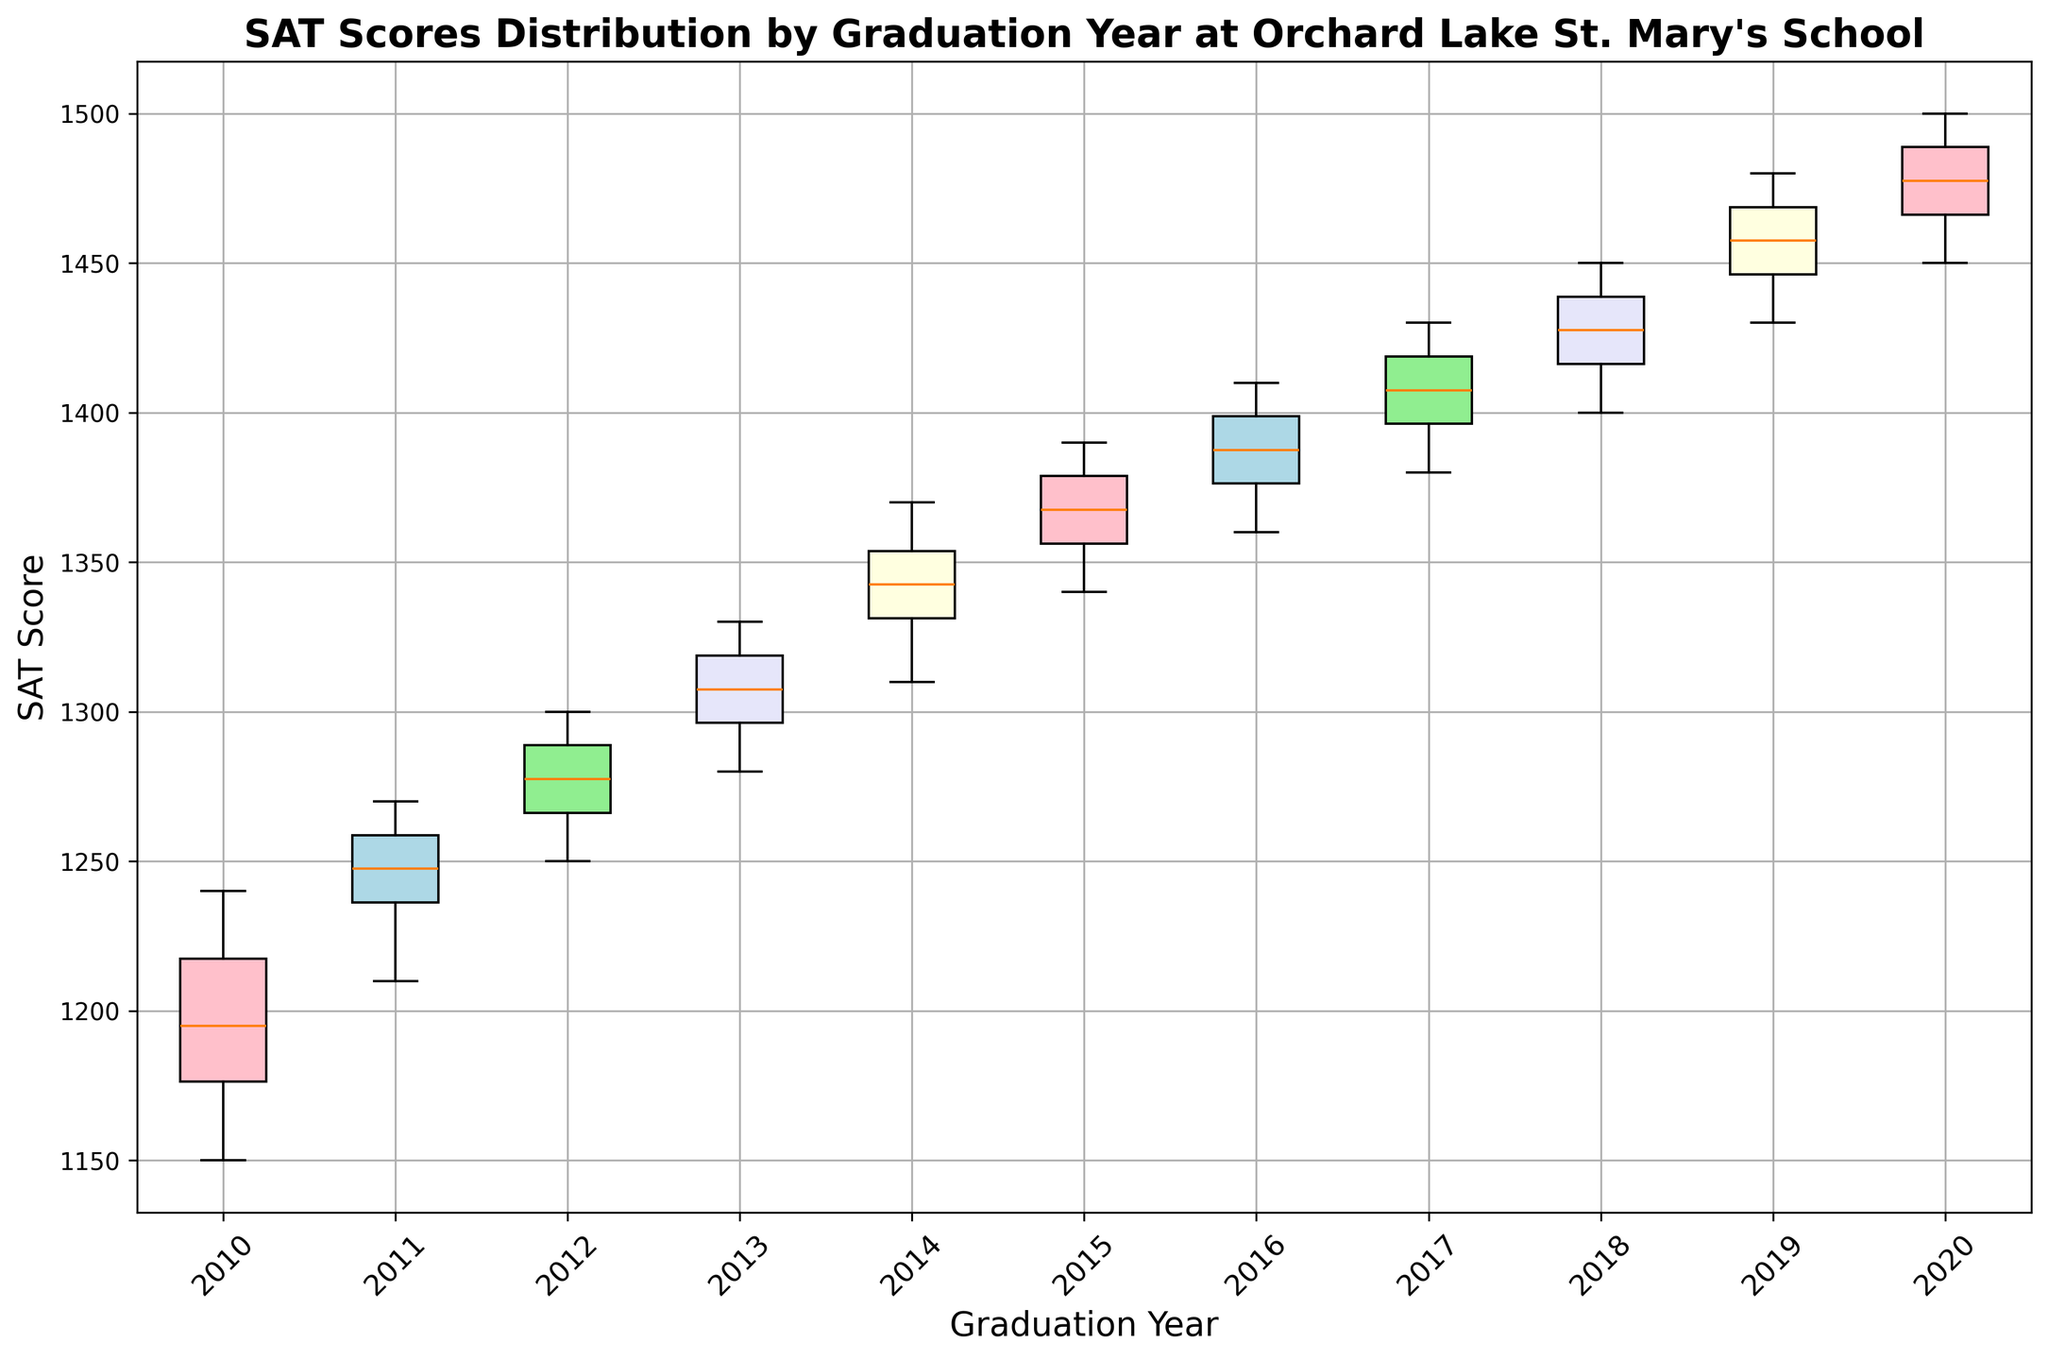What is the median SAT score for the class of 2015? To find the median SAT score for the class of 2015, locate the middle value of the ordered scores for that year. As there are 10 observations, the median is the average of the 5th and 6th highest scores. These scores are 1370 and 1380, so the median is (1370 + 1380) / 2.
Answer: 1375 Which graduation year has the highest median SAT score? Examine the median line inside each box plot for each year. The highest median line visually belongs to the class of 2020.
Answer: 2020 Which year has the largest interquartile range (IQR) in SAT scores? The IQR is the distance between the bottom and top edges of the box (the first and third quartiles). Visually compare the lengths of the boxes across all years. The class of 2020 exhibits the largest IQR.
Answer: 2020 Did any graduation year have an SAT score beyond 1500? Check for any dots or points (outliers) beyond the whiskers of the box plots exceeding the value of 1500. No such points are present in any of the years.
Answer: No Which year shows the smallest variability in SAT scores? The variability within a group is indicated by the length of the box and the range of whiskers. The class of 2010 displays the smallest box and whiskers, indicating the smallest variability.
Answer: 2010 If we considered the third quartile SAT score for the class of 2012 and subtracted the first quartile SAT score for the class of 2015, what would the result be? Identify the third quartile (upper edge of the box) for 2012 and the first quartile (lower edge of the box) for 2015. The third quartile for 2012 is around 1290 and the first quartile for 2015 is approximately 1350, so the difference is 1290 - 1350.
Answer: -60 Which year shows lower whiskers that overlap with other years' distributions? The lower whisker indicates the smallest value in a given class. The lower whiskers of all years generally overlap a wide range, but especially the 2010 lower whisker overlaps with higher parts of the whiskers of subsequent years.
Answer: 2010 Are there any years with no outliers present in the data? Outliers are represented as individual points outside the whiskers. On visual inspection, the years 2011 and 2012 do not show any outliers beyond the whiskers.
Answer: Yes, 2011 and 2012 What is the visual representation used to display the highest scores in each year? The highest scores for each year are represented by the top whisker of each box plot.
Answer: Top whisker 